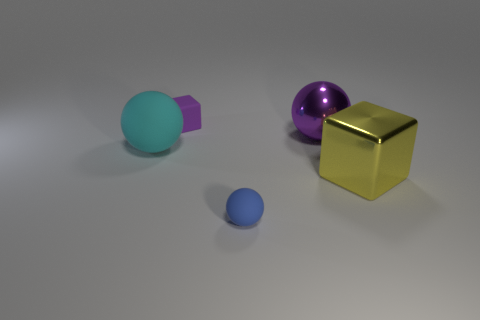If these objects were part of a game, what could be their potential uses or rules involving them? If this were a game, we could imagine the gold cube as a treasure to be captured, perhaps being the key to score points. The spheres might serve as objects to be collected or moved to specific locations on the game board. The purple object could function as an obstacle or a piece that changes game dynamics, such as altering the movement of the spheres when they come in contact. 